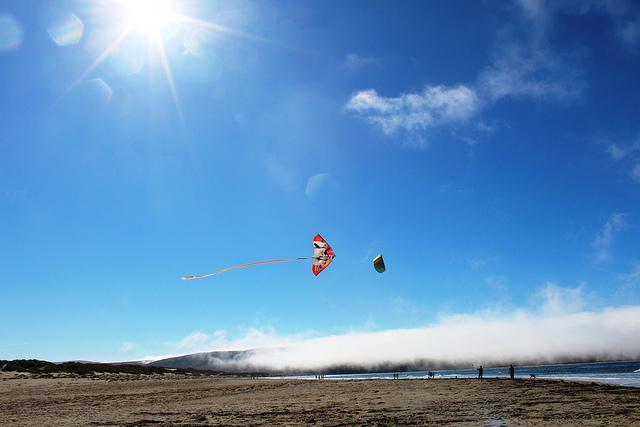Is the sky clear?
Write a very short answer. Yes. Is the photo in color?
Answer briefly. Yes. What sport can be played on the other side of the water?
Keep it brief. Surfing. Is that trees in the background?
Write a very short answer. No. What color is the kite?
Concise answer only. Red and white. What is the small white circle?
Short answer required. Sun. What bad weather condition is in the distance?
Concise answer only. Fog. Are there a lot of people in this photo?
Give a very brief answer. No. What color is the sky?
Write a very short answer. Blue. Is it a rainy day?
Answer briefly. No. How many people appear in the picture?
Quick response, please. 2. Are they aiming the kites towards the mountains?
Answer briefly. No. What is being flown?
Be succinct. Kite. What are three colors in this photo?
Be succinct. Blue, brown and white. What is the shape of the kite?
Keep it brief. Triangle. Was this photo taken near water?
Concise answer only. Yes. How many kites are in the sky?
Concise answer only. 2. 